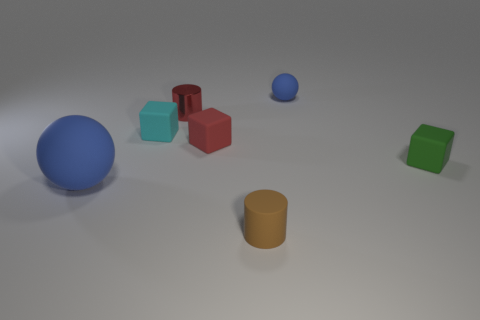What is the material of the big object that is the same color as the small ball?
Your response must be concise. Rubber. What is the size of the rubber sphere behind the blue matte object that is in front of the small rubber thing that is right of the tiny blue matte ball?
Ensure brevity in your answer.  Small. Is the number of small brown objects that are behind the rubber cylinder greater than the number of green rubber things that are on the right side of the green rubber object?
Offer a terse response. No. There is a tiny red rubber object right of the metal object; what number of tiny red metal cylinders are to the right of it?
Your answer should be very brief. 0. Is there another tiny rubber ball that has the same color as the small rubber sphere?
Give a very brief answer. No. Do the red rubber object and the green thing have the same size?
Your answer should be very brief. Yes. Is the small sphere the same color as the small rubber cylinder?
Provide a short and direct response. No. There is a blue object that is to the right of the sphere that is in front of the tiny blue thing; what is it made of?
Offer a terse response. Rubber. There is another small brown thing that is the same shape as the small metal object; what material is it?
Give a very brief answer. Rubber. Is the size of the blue rubber ball that is left of the red metal thing the same as the tiny red metallic thing?
Your answer should be compact. No. 